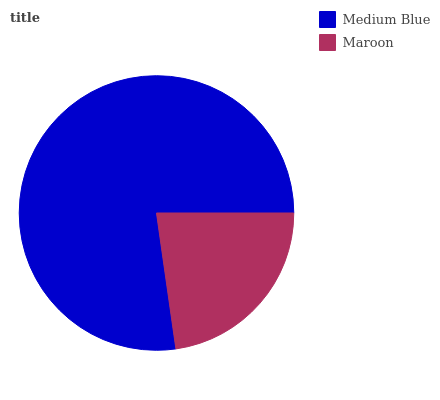Is Maroon the minimum?
Answer yes or no. Yes. Is Medium Blue the maximum?
Answer yes or no. Yes. Is Maroon the maximum?
Answer yes or no. No. Is Medium Blue greater than Maroon?
Answer yes or no. Yes. Is Maroon less than Medium Blue?
Answer yes or no. Yes. Is Maroon greater than Medium Blue?
Answer yes or no. No. Is Medium Blue less than Maroon?
Answer yes or no. No. Is Medium Blue the high median?
Answer yes or no. Yes. Is Maroon the low median?
Answer yes or no. Yes. Is Maroon the high median?
Answer yes or no. No. Is Medium Blue the low median?
Answer yes or no. No. 